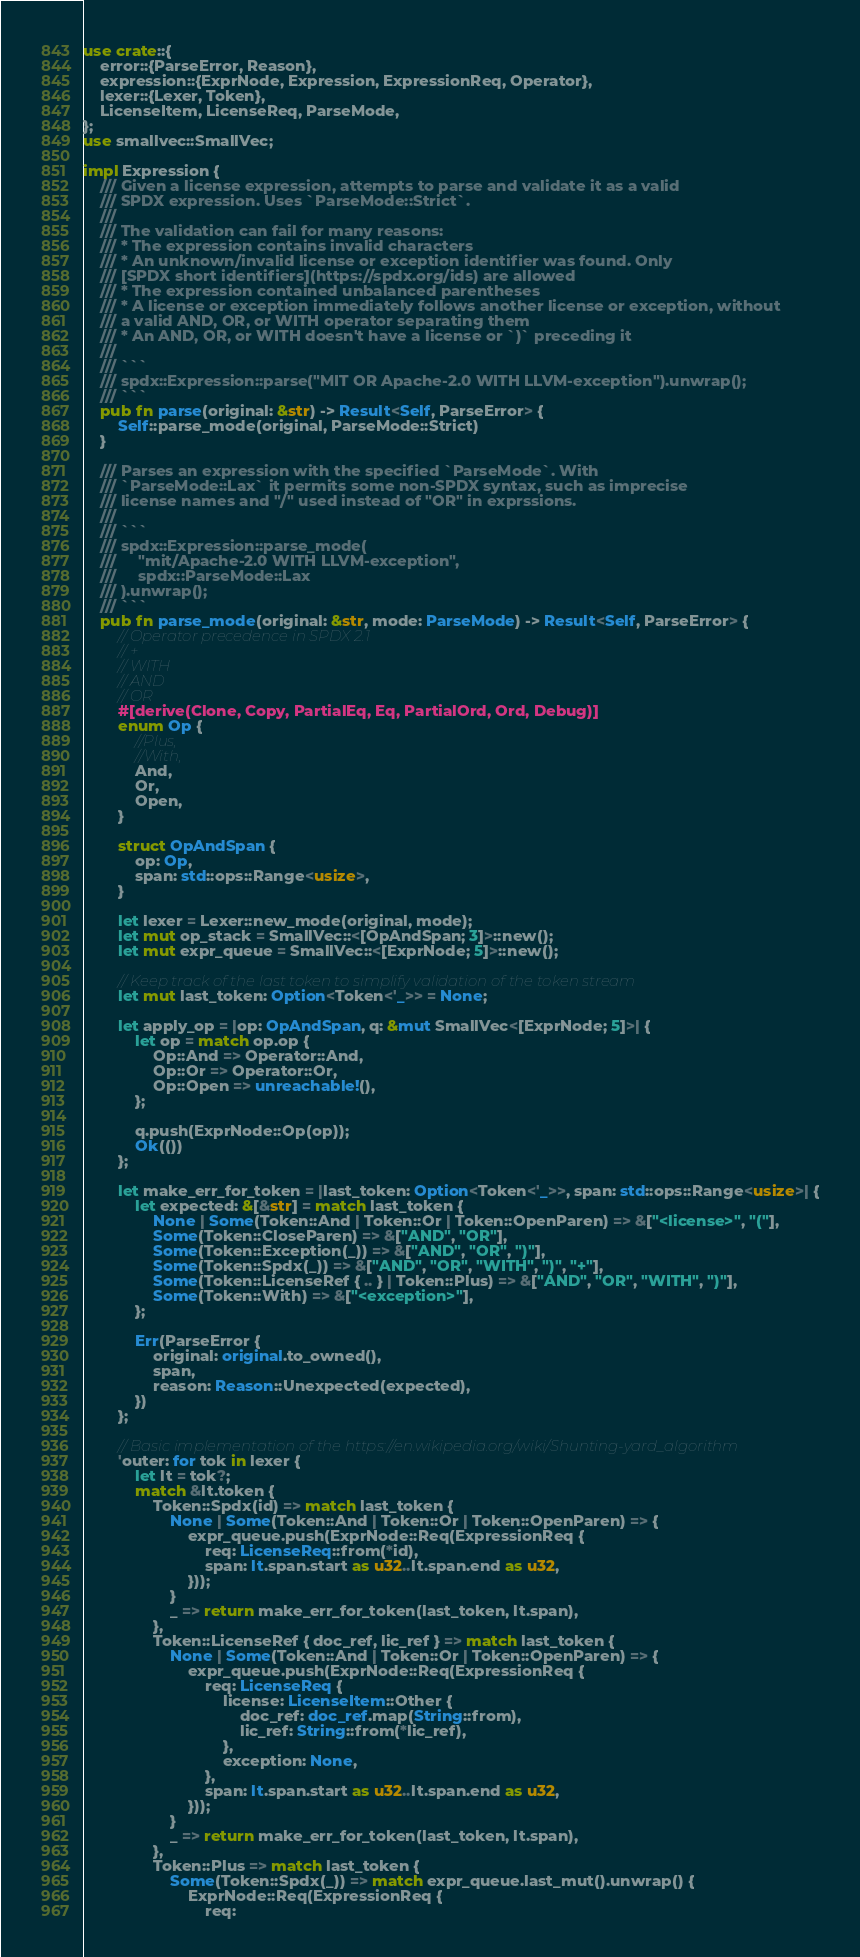Convert code to text. <code><loc_0><loc_0><loc_500><loc_500><_Rust_>use crate::{
    error::{ParseError, Reason},
    expression::{ExprNode, Expression, ExpressionReq, Operator},
    lexer::{Lexer, Token},
    LicenseItem, LicenseReq, ParseMode,
};
use smallvec::SmallVec;

impl Expression {
    /// Given a license expression, attempts to parse and validate it as a valid
    /// SPDX expression. Uses `ParseMode::Strict`.
    ///
    /// The validation can fail for many reasons:
    /// * The expression contains invalid characters
    /// * An unknown/invalid license or exception identifier was found. Only
    /// [SPDX short identifiers](https://spdx.org/ids) are allowed
    /// * The expression contained unbalanced parentheses
    /// * A license or exception immediately follows another license or exception, without
    /// a valid AND, OR, or WITH operator separating them
    /// * An AND, OR, or WITH doesn't have a license or `)` preceding it
    ///
    /// ```
    /// spdx::Expression::parse("MIT OR Apache-2.0 WITH LLVM-exception").unwrap();
    /// ```
    pub fn parse(original: &str) -> Result<Self, ParseError> {
        Self::parse_mode(original, ParseMode::Strict)
    }

    /// Parses an expression with the specified `ParseMode`. With
    /// `ParseMode::Lax` it permits some non-SPDX syntax, such as imprecise
    /// license names and "/" used instead of "OR" in exprssions.
    ///
    /// ```
    /// spdx::Expression::parse_mode(
    ///     "mit/Apache-2.0 WITH LLVM-exception",
    ///     spdx::ParseMode::Lax
    /// ).unwrap();
    /// ```
    pub fn parse_mode(original: &str, mode: ParseMode) -> Result<Self, ParseError> {
        // Operator precedence in SPDX 2.1
        // +
        // WITH
        // AND
        // OR
        #[derive(Clone, Copy, PartialEq, Eq, PartialOrd, Ord, Debug)]
        enum Op {
            //Plus,
            //With,
            And,
            Or,
            Open,
        }

        struct OpAndSpan {
            op: Op,
            span: std::ops::Range<usize>,
        }

        let lexer = Lexer::new_mode(original, mode);
        let mut op_stack = SmallVec::<[OpAndSpan; 3]>::new();
        let mut expr_queue = SmallVec::<[ExprNode; 5]>::new();

        // Keep track of the last token to simplify validation of the token stream
        let mut last_token: Option<Token<'_>> = None;

        let apply_op = |op: OpAndSpan, q: &mut SmallVec<[ExprNode; 5]>| {
            let op = match op.op {
                Op::And => Operator::And,
                Op::Or => Operator::Or,
                Op::Open => unreachable!(),
            };

            q.push(ExprNode::Op(op));
            Ok(())
        };

        let make_err_for_token = |last_token: Option<Token<'_>>, span: std::ops::Range<usize>| {
            let expected: &[&str] = match last_token {
                None | Some(Token::And | Token::Or | Token::OpenParen) => &["<license>", "("],
                Some(Token::CloseParen) => &["AND", "OR"],
                Some(Token::Exception(_)) => &["AND", "OR", ")"],
                Some(Token::Spdx(_)) => &["AND", "OR", "WITH", ")", "+"],
                Some(Token::LicenseRef { .. } | Token::Plus) => &["AND", "OR", "WITH", ")"],
                Some(Token::With) => &["<exception>"],
            };

            Err(ParseError {
                original: original.to_owned(),
                span,
                reason: Reason::Unexpected(expected),
            })
        };

        // Basic implementation of the https://en.wikipedia.org/wiki/Shunting-yard_algorithm
        'outer: for tok in lexer {
            let lt = tok?;
            match &lt.token {
                Token::Spdx(id) => match last_token {
                    None | Some(Token::And | Token::Or | Token::OpenParen) => {
                        expr_queue.push(ExprNode::Req(ExpressionReq {
                            req: LicenseReq::from(*id),
                            span: lt.span.start as u32..lt.span.end as u32,
                        }));
                    }
                    _ => return make_err_for_token(last_token, lt.span),
                },
                Token::LicenseRef { doc_ref, lic_ref } => match last_token {
                    None | Some(Token::And | Token::Or | Token::OpenParen) => {
                        expr_queue.push(ExprNode::Req(ExpressionReq {
                            req: LicenseReq {
                                license: LicenseItem::Other {
                                    doc_ref: doc_ref.map(String::from),
                                    lic_ref: String::from(*lic_ref),
                                },
                                exception: None,
                            },
                            span: lt.span.start as u32..lt.span.end as u32,
                        }));
                    }
                    _ => return make_err_for_token(last_token, lt.span),
                },
                Token::Plus => match last_token {
                    Some(Token::Spdx(_)) => match expr_queue.last_mut().unwrap() {
                        ExprNode::Req(ExpressionReq {
                            req:</code> 